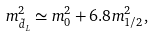Convert formula to latex. <formula><loc_0><loc_0><loc_500><loc_500>m ^ { 2 } _ { \tilde { d } _ { L } } \simeq m _ { 0 } ^ { 2 } + 6 . 8 m ^ { 2 } _ { 1 / 2 } ,</formula> 